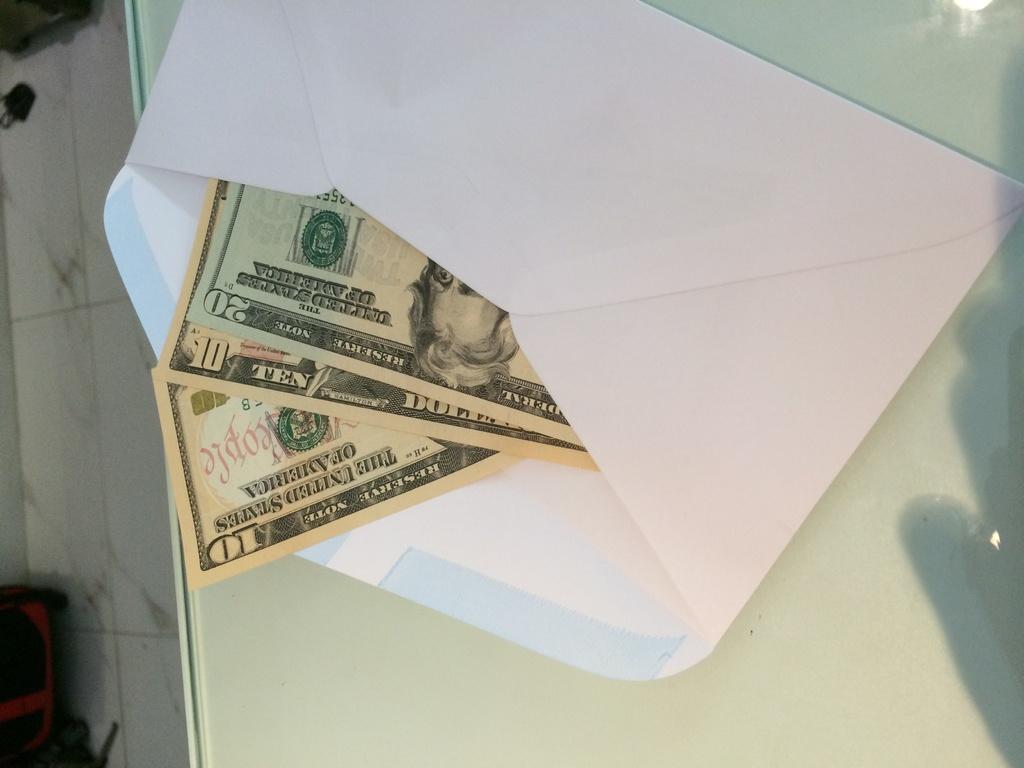Is there a 10 dollar bill in here?
Provide a succinct answer. Yes. 